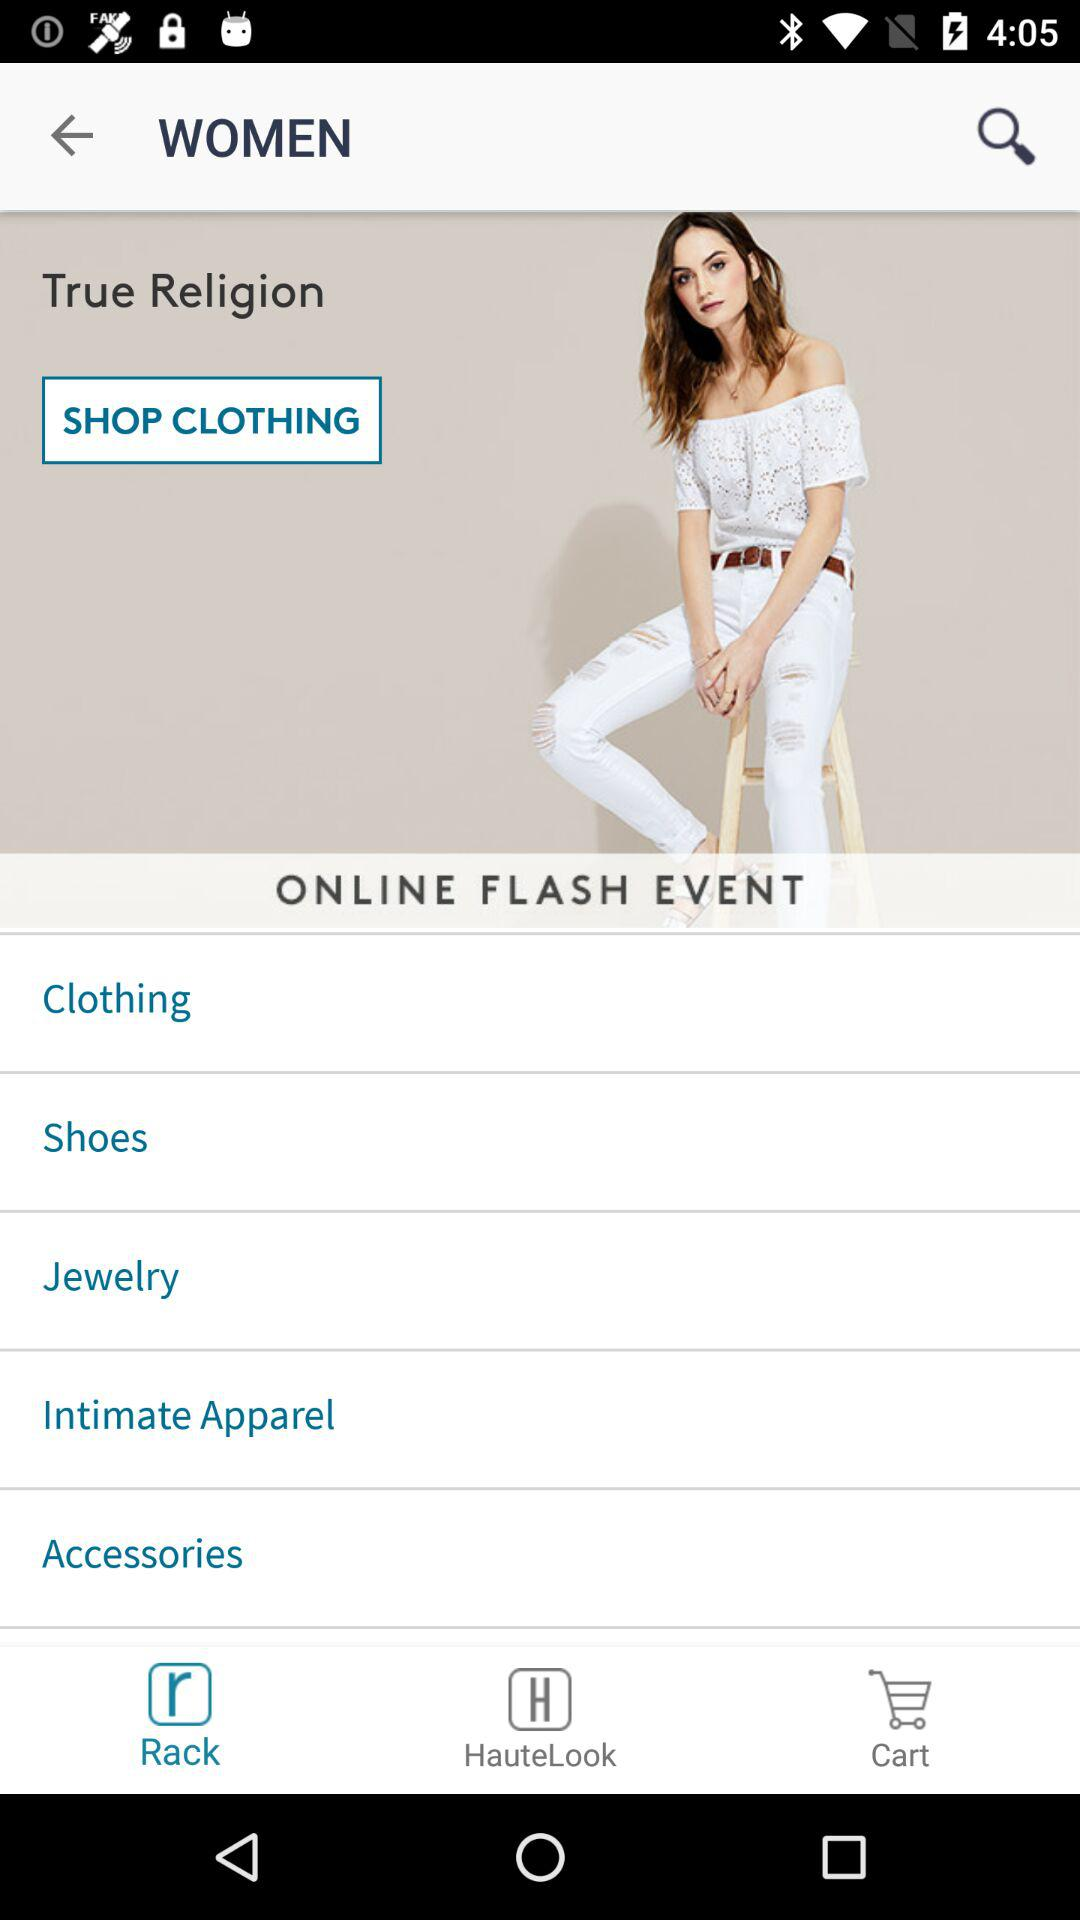Which online flash events are being shown on screen?
When the provided information is insufficient, respond with <no answer>. <no answer> 